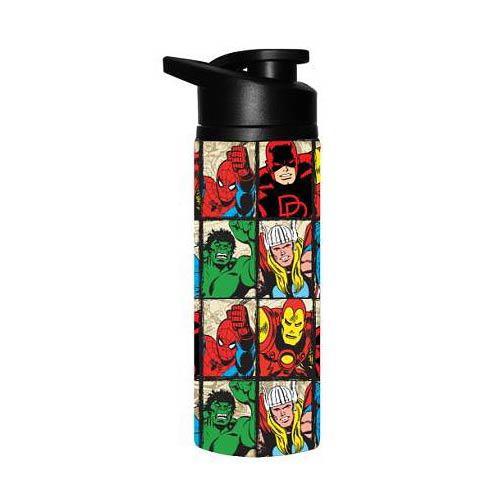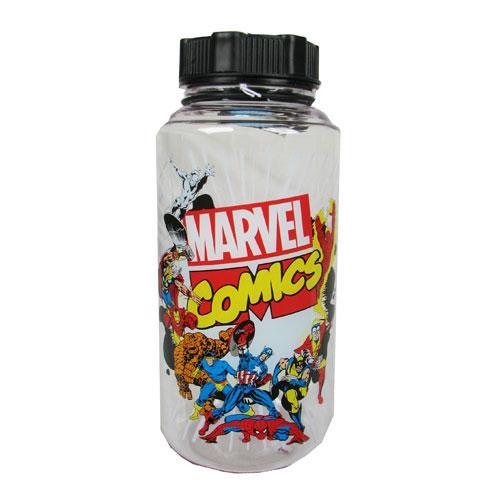The first image is the image on the left, the second image is the image on the right. Considering the images on both sides, is "Each water bottle has a black lid, and one water bottle has a grid of at least six square super hero pictures on its front." valid? Answer yes or no. Yes. The first image is the image on the left, the second image is the image on the right. For the images displayed, is the sentence "There is a bottle with a red lid." factually correct? Answer yes or no. No. 